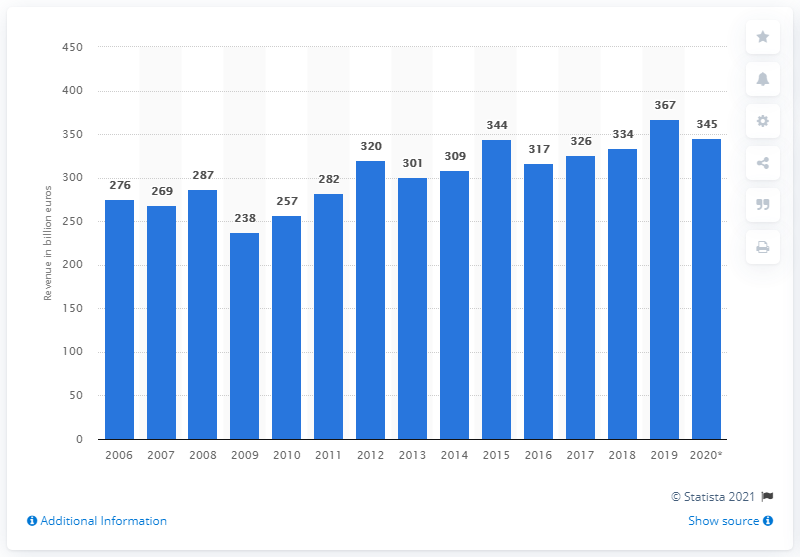List a handful of essential elements in this visual. In 2020, the market for mechanical engineering in the United States was 345. 